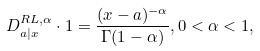Convert formula to latex. <formula><loc_0><loc_0><loc_500><loc_500>D ^ { R L , \alpha } _ { a | x } \cdot 1 = \frac { ( x - a ) ^ { - \alpha } } { \Gamma ( 1 - \alpha ) } , 0 < \alpha < 1 ,</formula> 